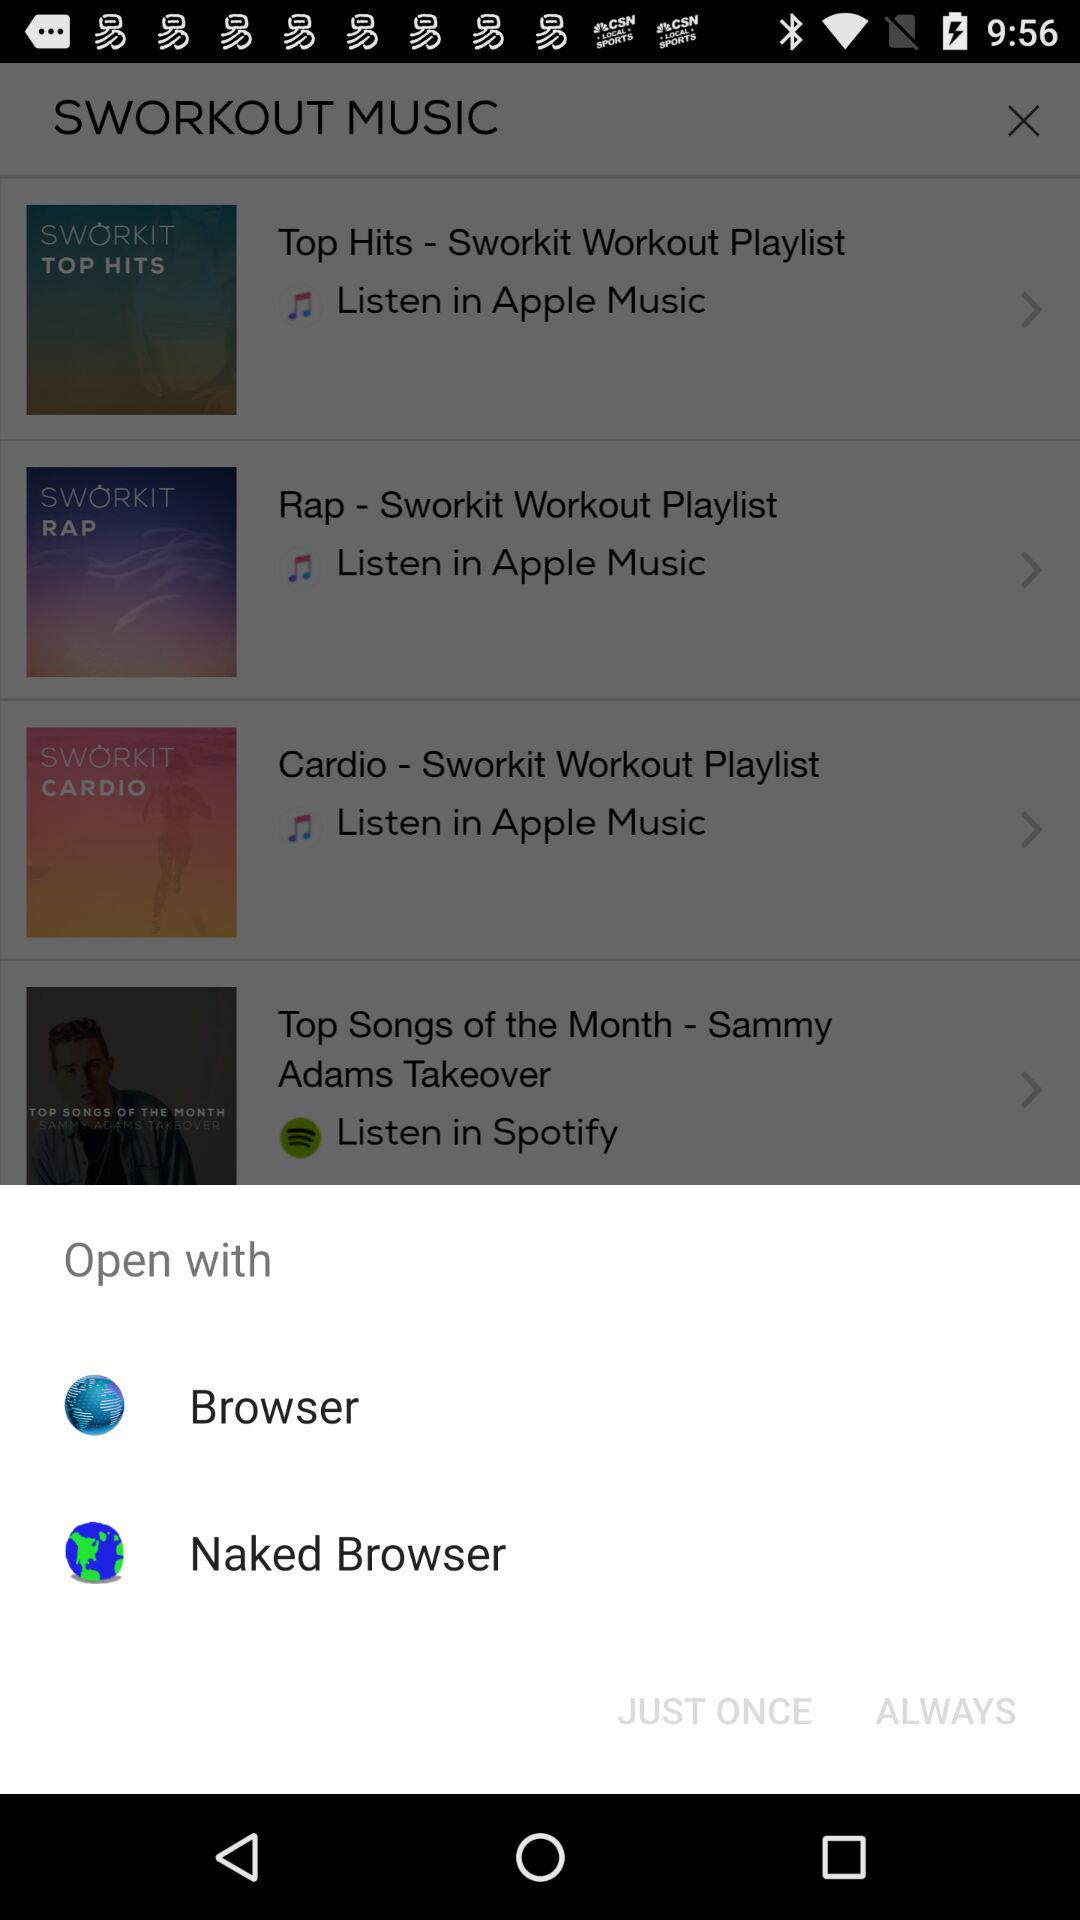What applications can be used to open? The applications that can be used to open are "Browser" and "Naked Browser". 